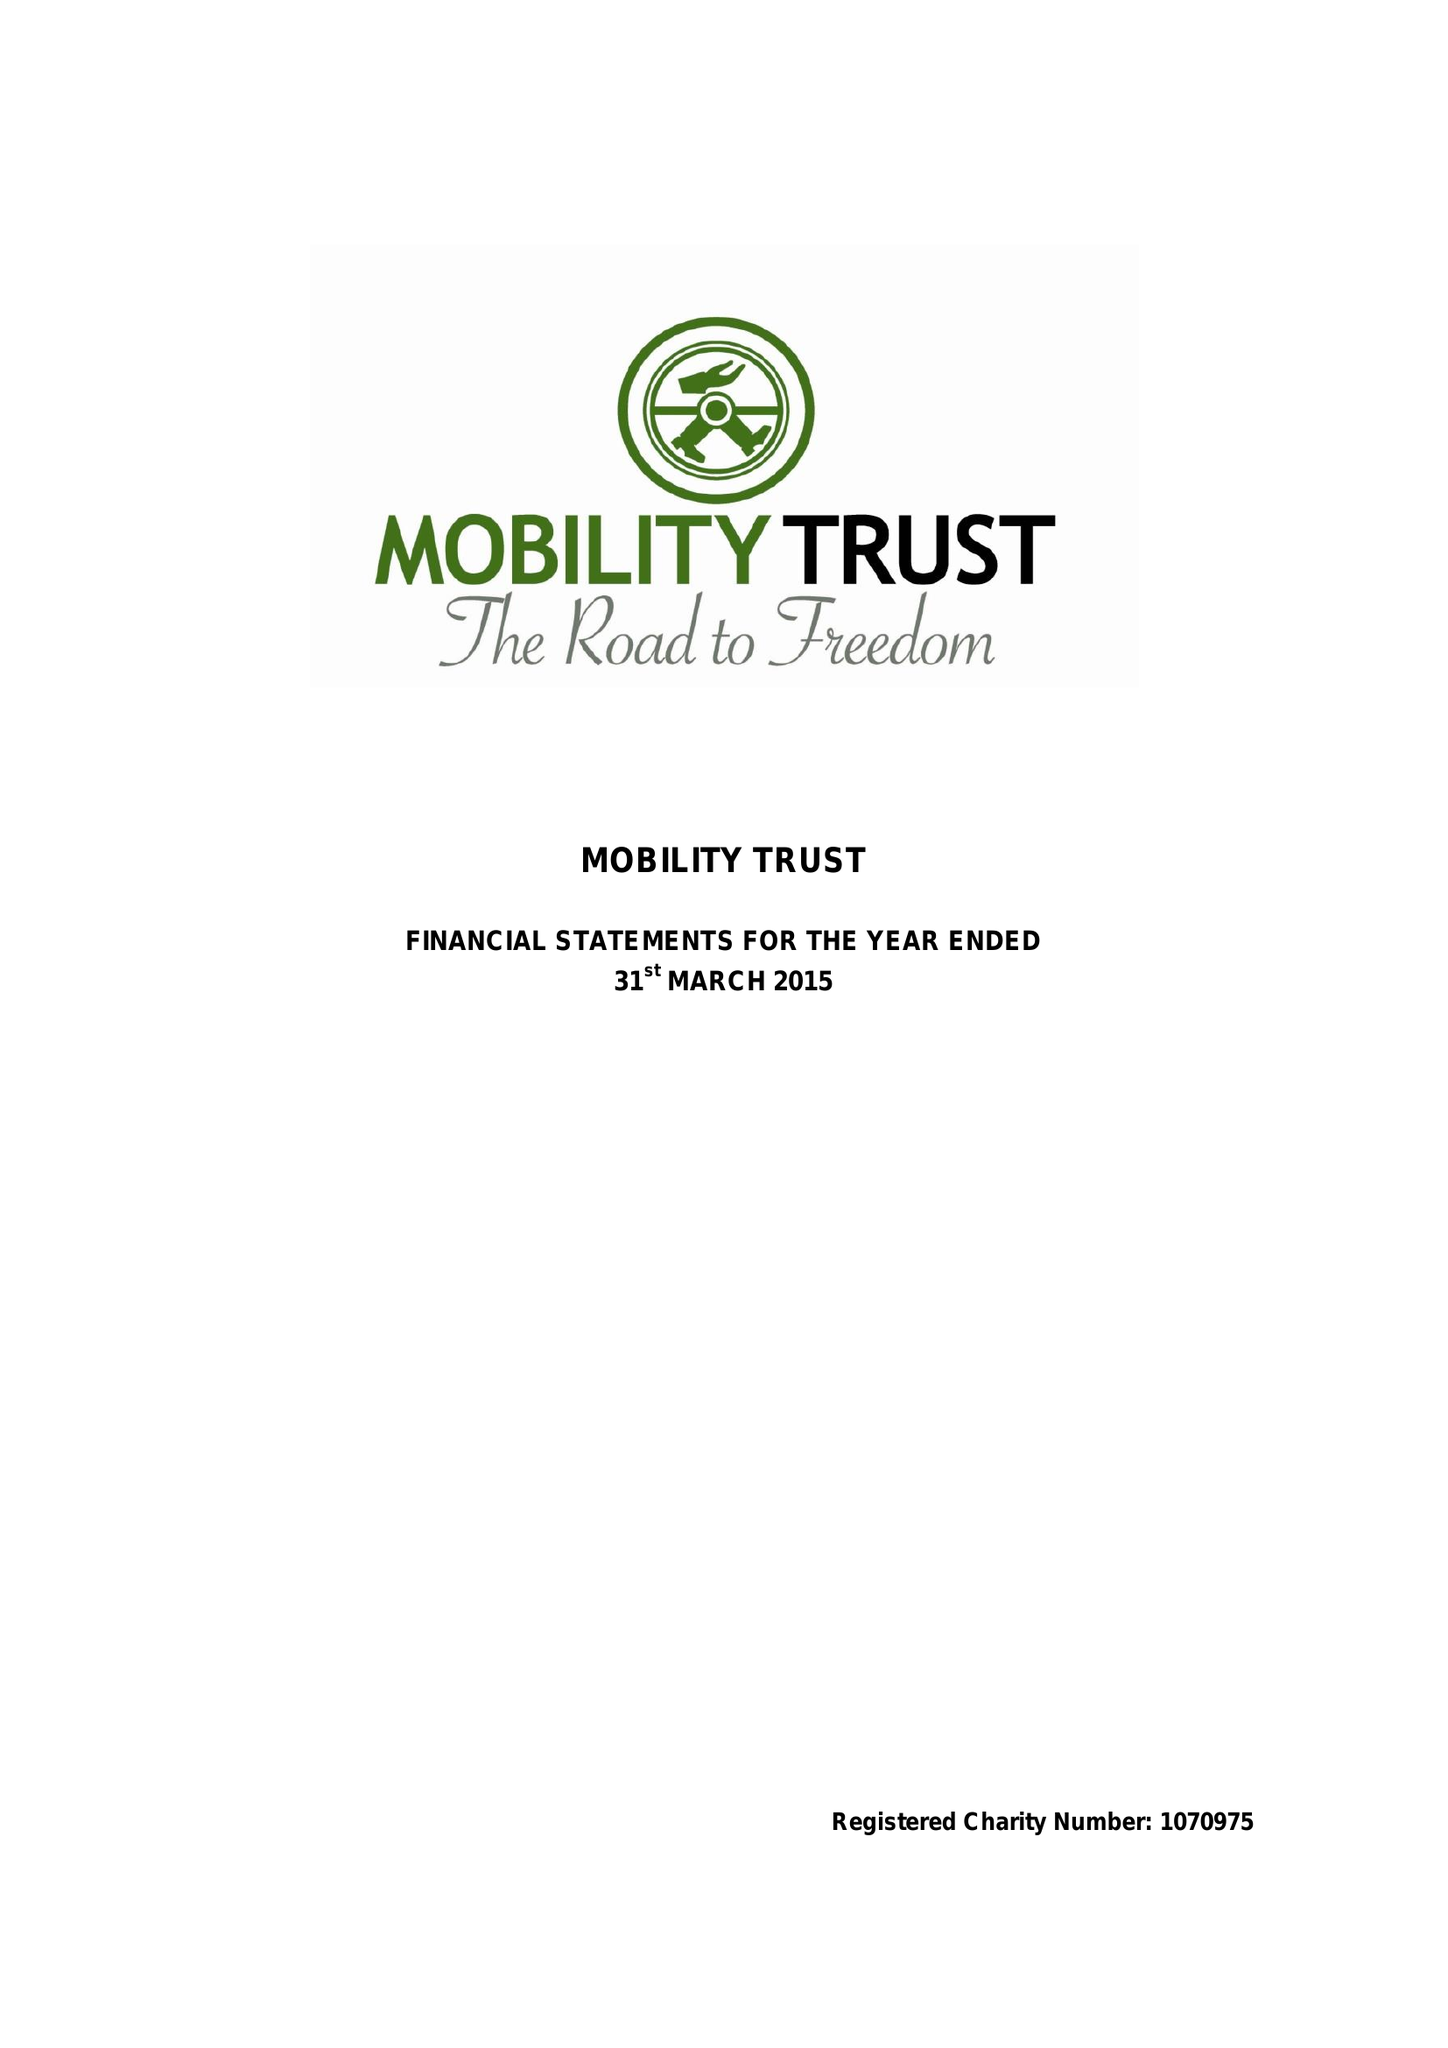What is the value for the address__street_line?
Answer the question using a single word or phrase. 19 READING ROAD 